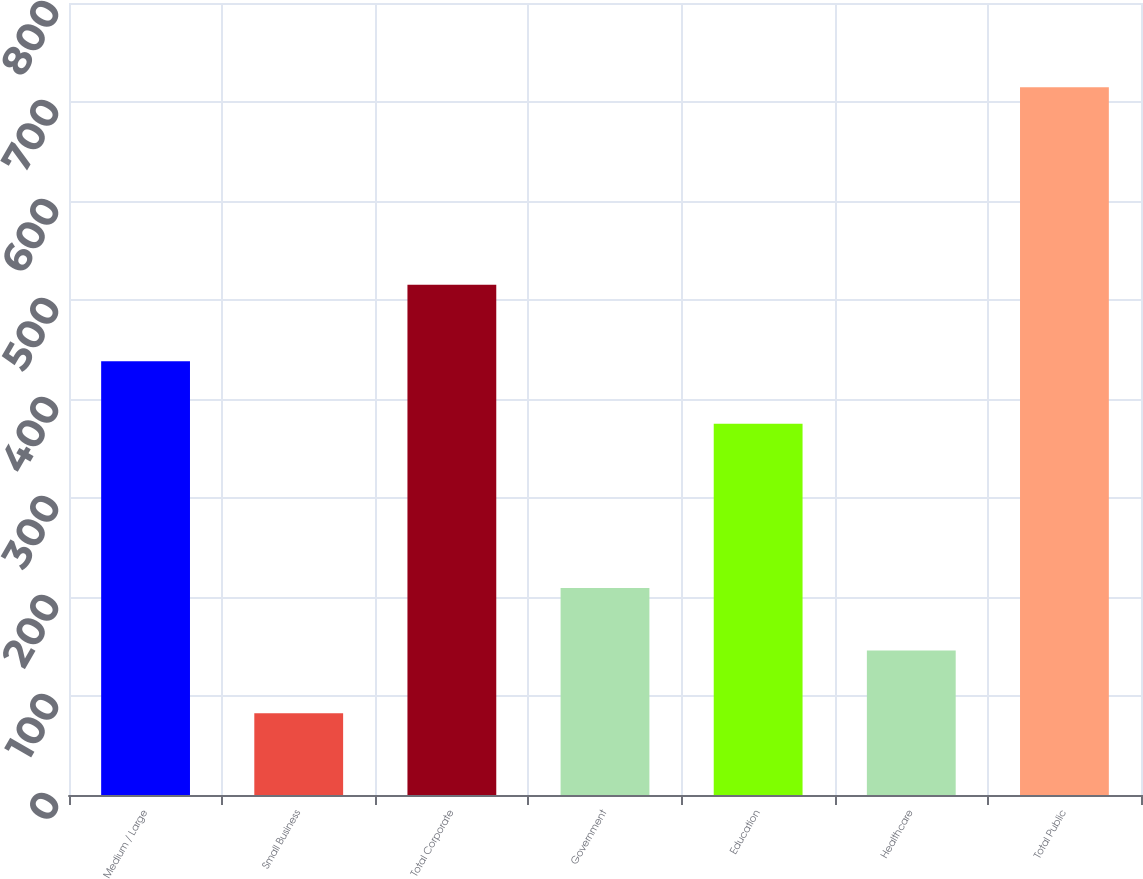Convert chart. <chart><loc_0><loc_0><loc_500><loc_500><bar_chart><fcel>Medium / Large<fcel>Small Business<fcel>Total Corporate<fcel>Government<fcel>Education<fcel>Healthcare<fcel>Total Public<nl><fcel>438.22<fcel>82.7<fcel>515.4<fcel>209.14<fcel>375<fcel>145.92<fcel>714.9<nl></chart> 